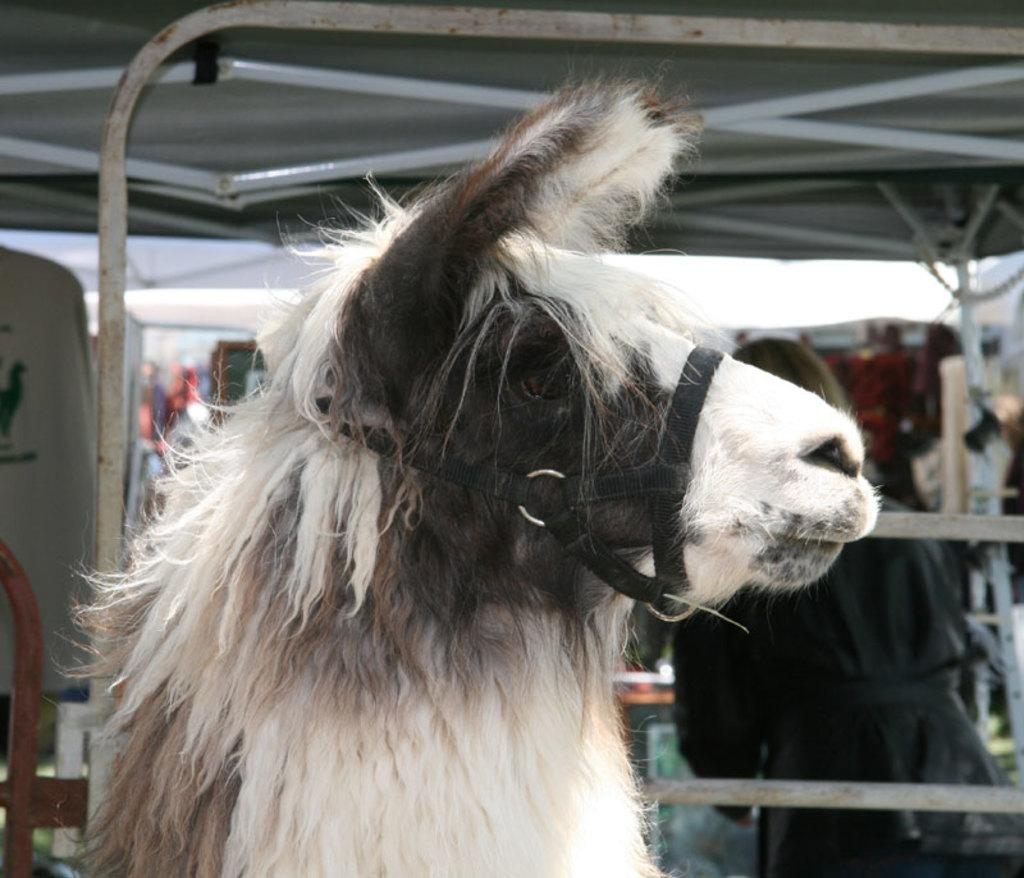What animal is present in the image? There is a horse in the image. What structure can be seen in the background of the image? There is a shed in the background of the image. Can you describe the person's location in the image? There is a person inside the shed. What type of stew is being prepared on the canvas in the image? There is no stew or canvas present in the image. 